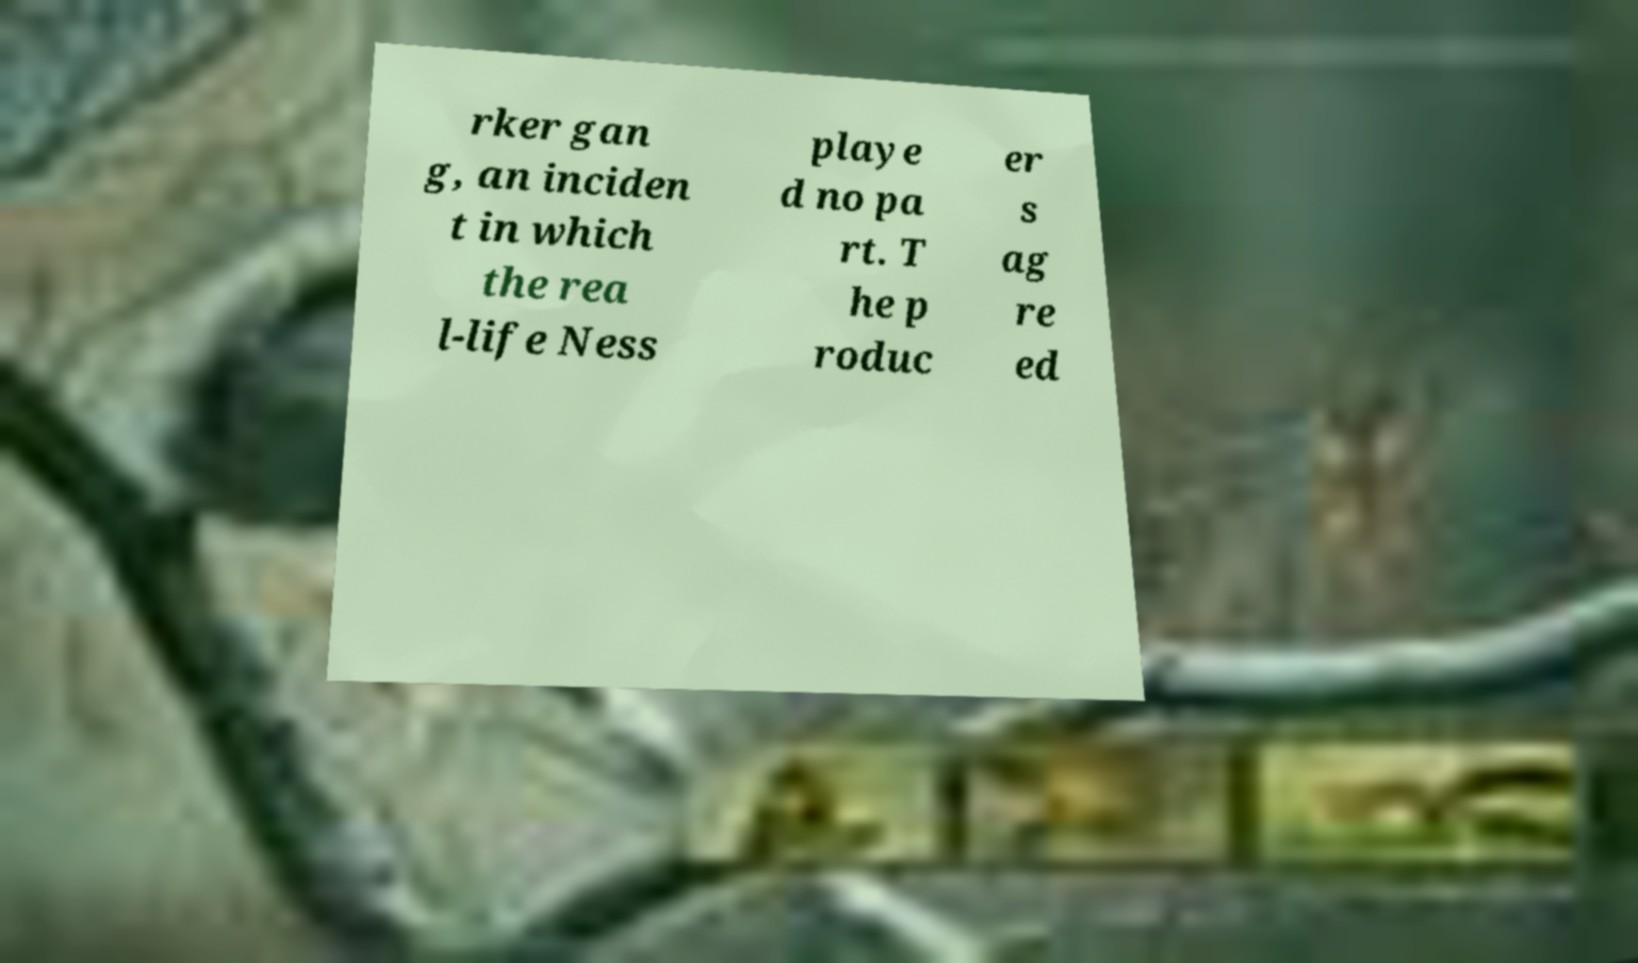Please read and relay the text visible in this image. What does it say? rker gan g, an inciden t in which the rea l-life Ness playe d no pa rt. T he p roduc er s ag re ed 